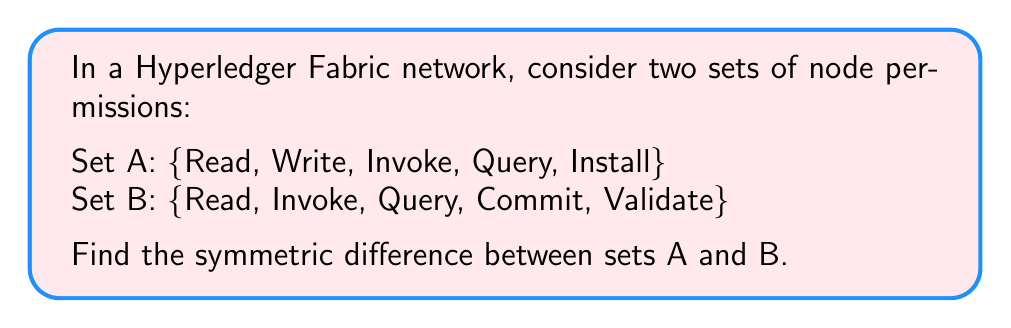Can you solve this math problem? To find the symmetric difference between two sets, we need to follow these steps:

1. Identify the elements that are in set A but not in set B.
2. Identify the elements that are in set B but not in set A.
3. Combine the results from steps 1 and 2.

Let's denote the symmetric difference as $A \triangle B$.

Step 1: Elements in A but not in B
$A \setminus B = \{Write, Install\}$

Step 2: Elements in B but not in A
$B \setminus A = \{Commit, Validate\}$

Step 3: Combine the results
$A \triangle B = (A \setminus B) \cup (B \setminus A)$

Therefore,
$A \triangle B = \{Write, Install\} \cup \{Commit, Validate\}$
$A \triangle B = \{Write, Install, Commit, Validate\}$

The symmetric difference gives us the set of permissions that are unique to each set, effectively showing the differences in node permissions between the two sets in the Hyperledger Fabric network.
Answer: $A \triangle B = \{Write, Install, Commit, Validate\}$ 